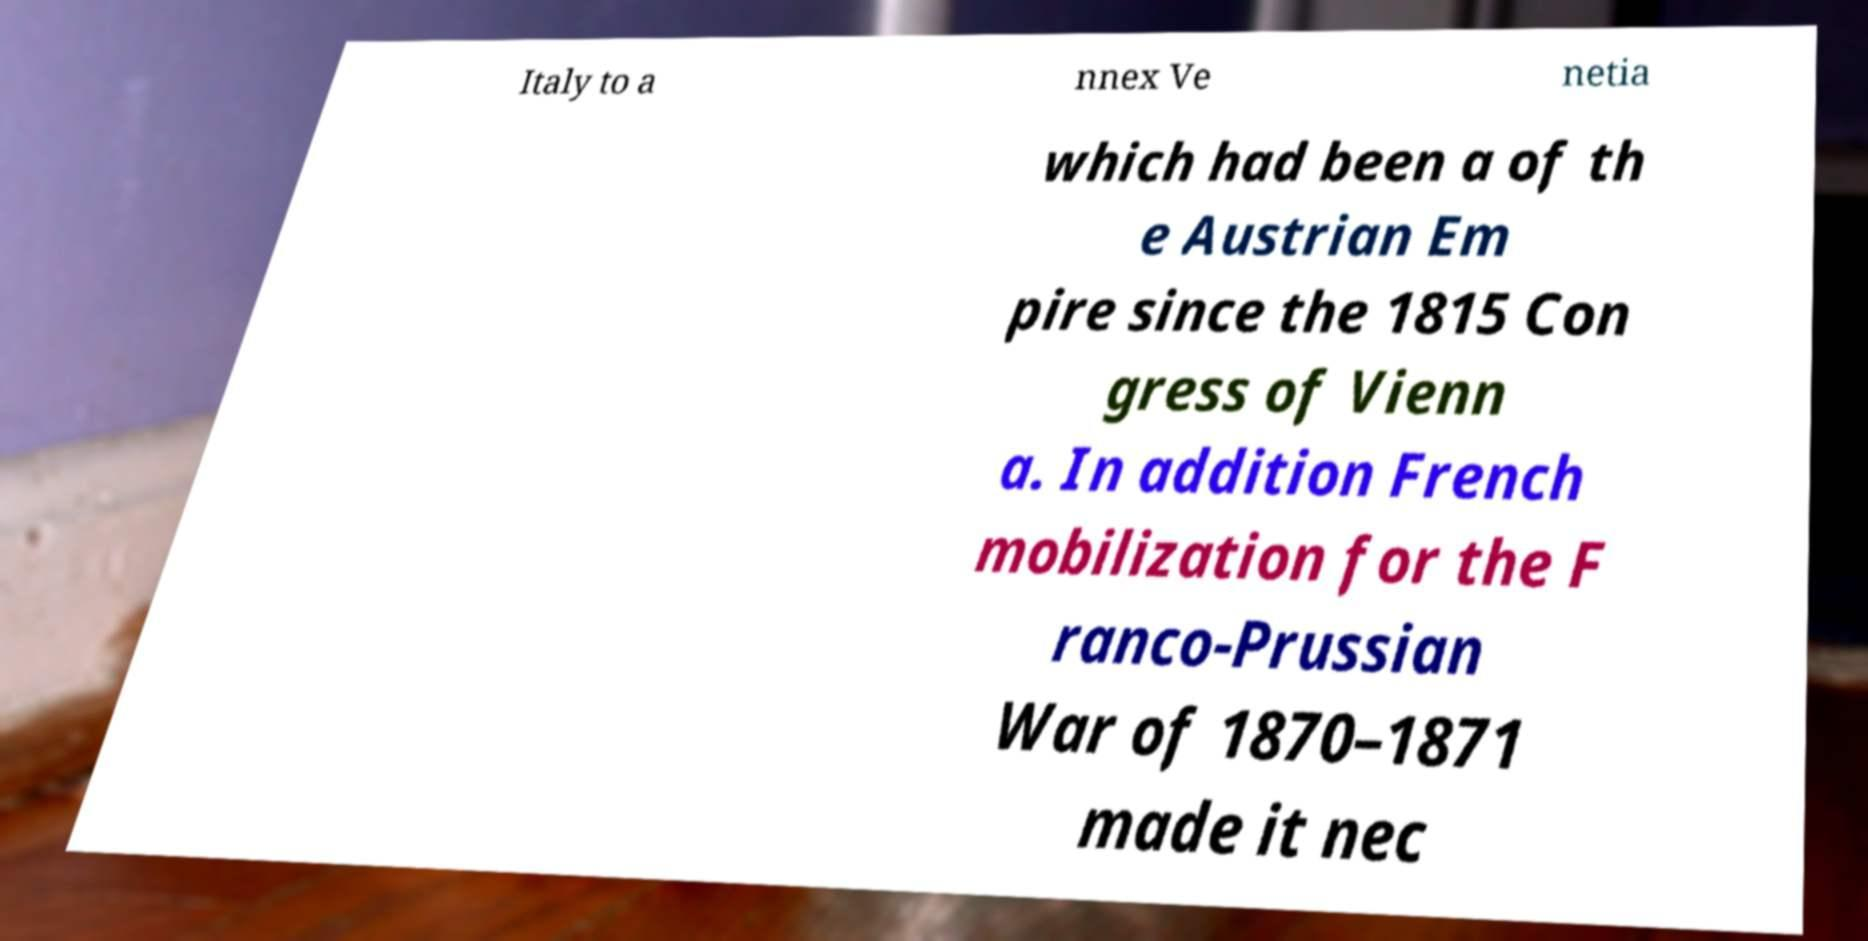Please identify and transcribe the text found in this image. Italy to a nnex Ve netia which had been a of th e Austrian Em pire since the 1815 Con gress of Vienn a. In addition French mobilization for the F ranco-Prussian War of 1870–1871 made it nec 